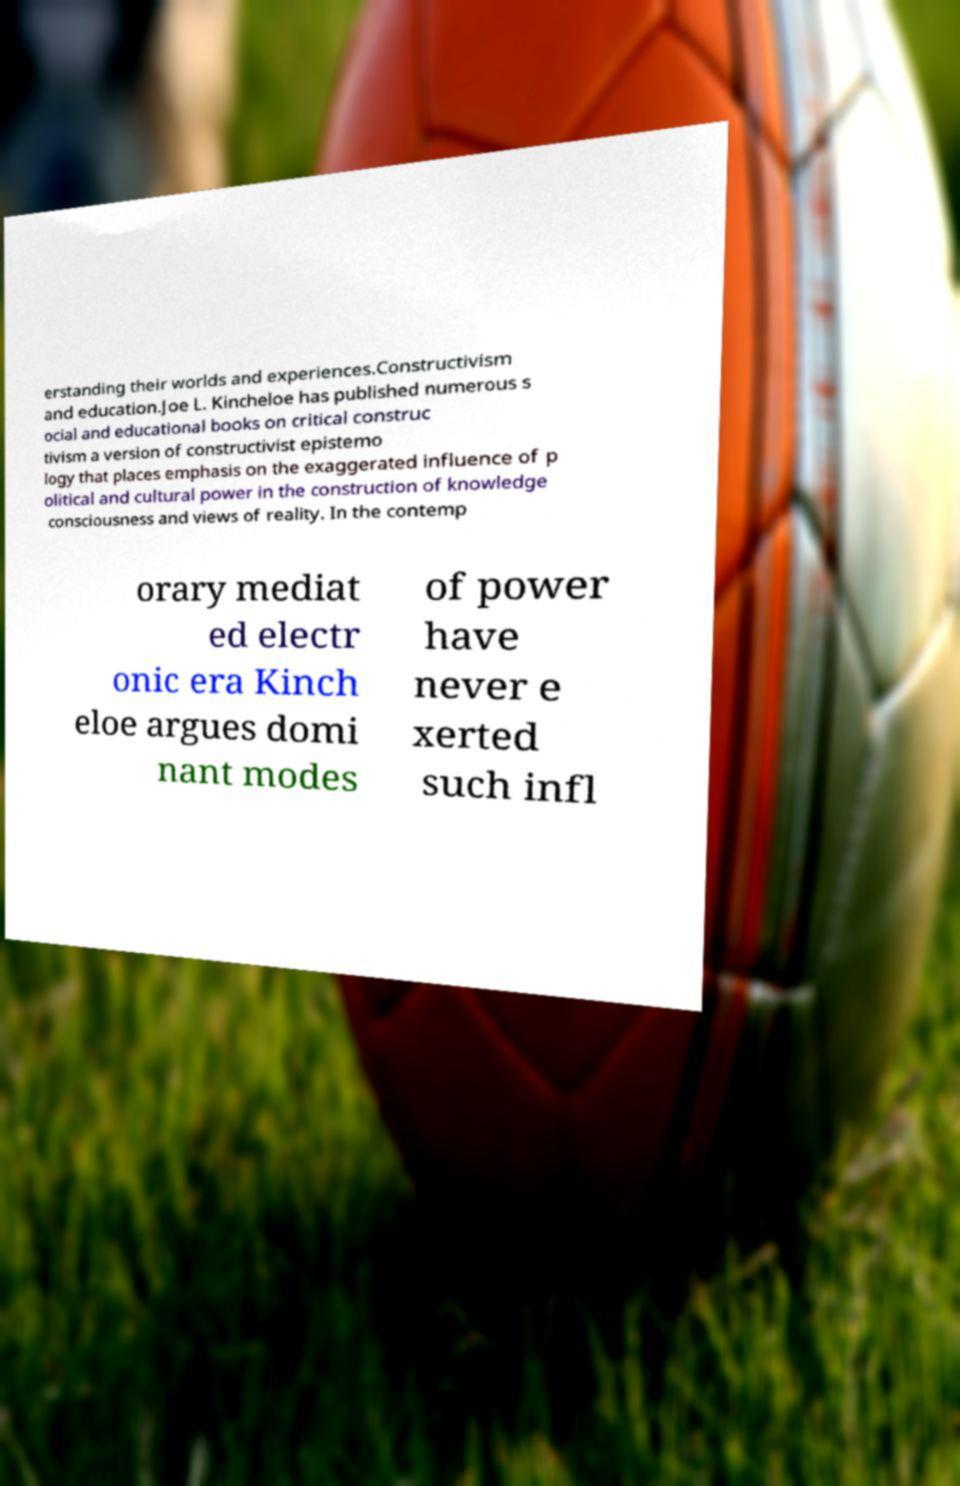What messages or text are displayed in this image? I need them in a readable, typed format. erstanding their worlds and experiences.Constructivism and education.Joe L. Kincheloe has published numerous s ocial and educational books on critical construc tivism a version of constructivist epistemo logy that places emphasis on the exaggerated influence of p olitical and cultural power in the construction of knowledge consciousness and views of reality. In the contemp orary mediat ed electr onic era Kinch eloe argues domi nant modes of power have never e xerted such infl 